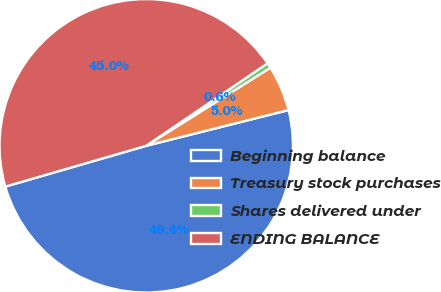Convert chart. <chart><loc_0><loc_0><loc_500><loc_500><pie_chart><fcel>Beginning balance<fcel>Treasury stock purchases<fcel>Shares delivered under<fcel>ENDING BALANCE<nl><fcel>49.43%<fcel>5.02%<fcel>0.57%<fcel>44.98%<nl></chart> 